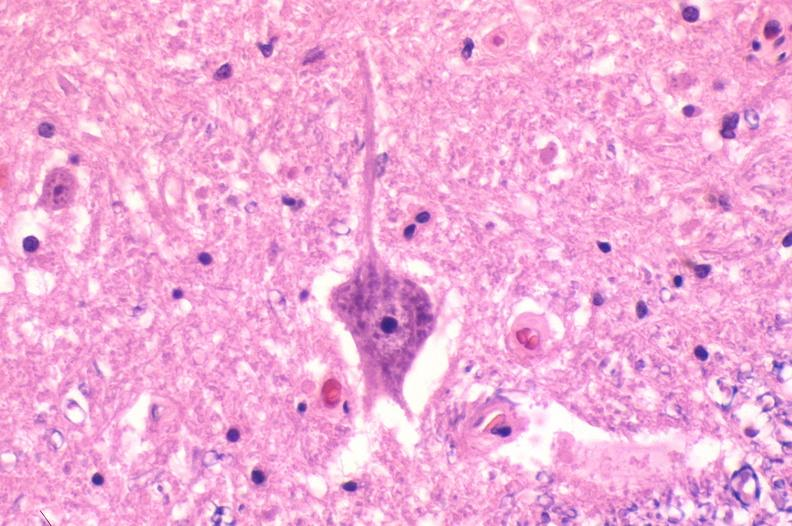what is present?
Answer the question using a single word or phrase. Nervous 